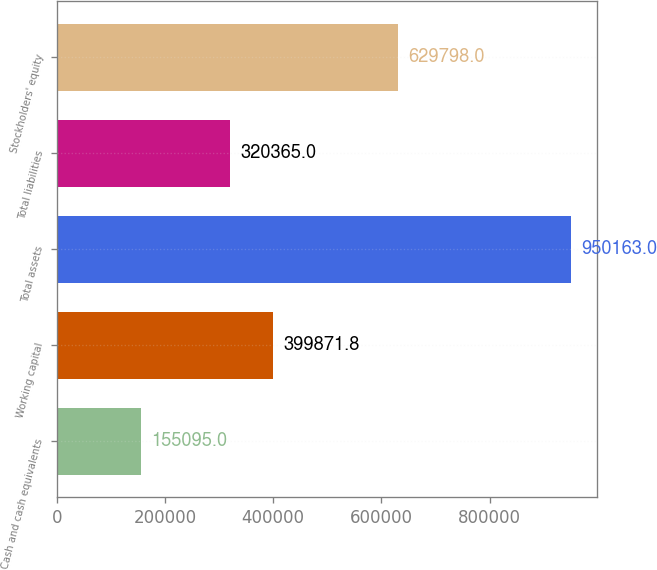<chart> <loc_0><loc_0><loc_500><loc_500><bar_chart><fcel>Cash and cash equivalents<fcel>Working capital<fcel>Total assets<fcel>Total liabilities<fcel>Stockholders' equity<nl><fcel>155095<fcel>399872<fcel>950163<fcel>320365<fcel>629798<nl></chart> 